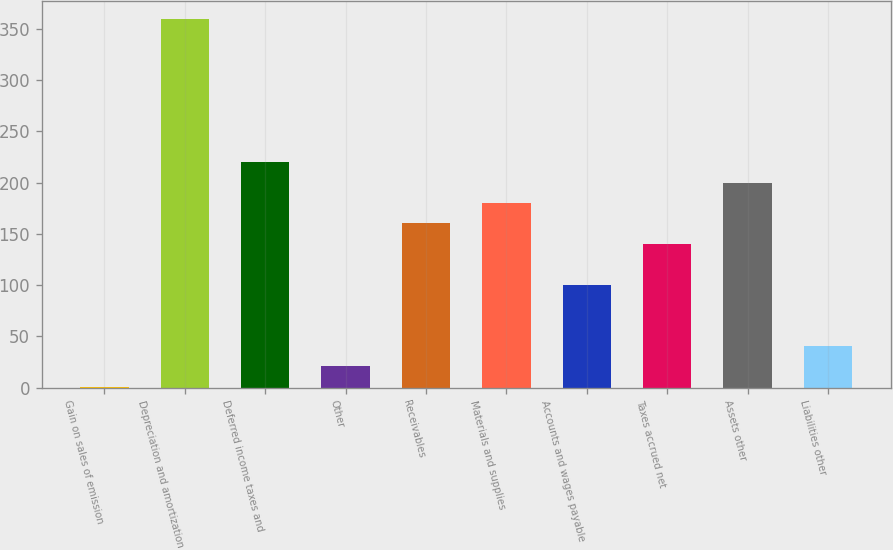Convert chart. <chart><loc_0><loc_0><loc_500><loc_500><bar_chart><fcel>Gain on sales of emission<fcel>Depreciation and amortization<fcel>Deferred income taxes and<fcel>Other<fcel>Receivables<fcel>Materials and supplies<fcel>Accounts and wages payable<fcel>Taxes accrued net<fcel>Assets other<fcel>Liabilities other<nl><fcel>1<fcel>359.2<fcel>219.9<fcel>20.9<fcel>160.2<fcel>180.1<fcel>100.5<fcel>140.3<fcel>200<fcel>40.8<nl></chart> 